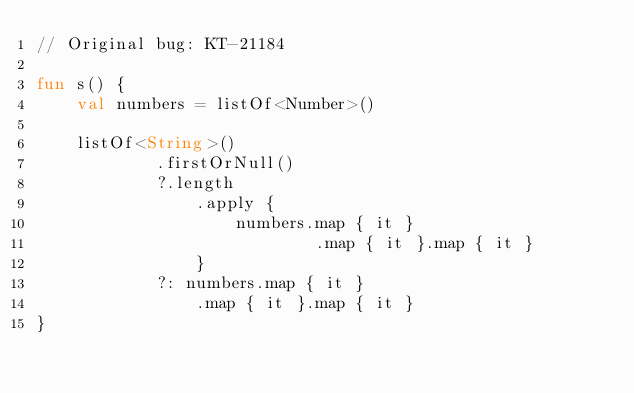Convert code to text. <code><loc_0><loc_0><loc_500><loc_500><_Kotlin_>// Original bug: KT-21184

fun s() {
    val numbers = listOf<Number>()

    listOf<String>()
            .firstOrNull()
            ?.length
                .apply {
                    numbers.map { it }
                            .map { it }.map { it }
                }
            ?: numbers.map { it }
                .map { it }.map { it }
}
</code> 